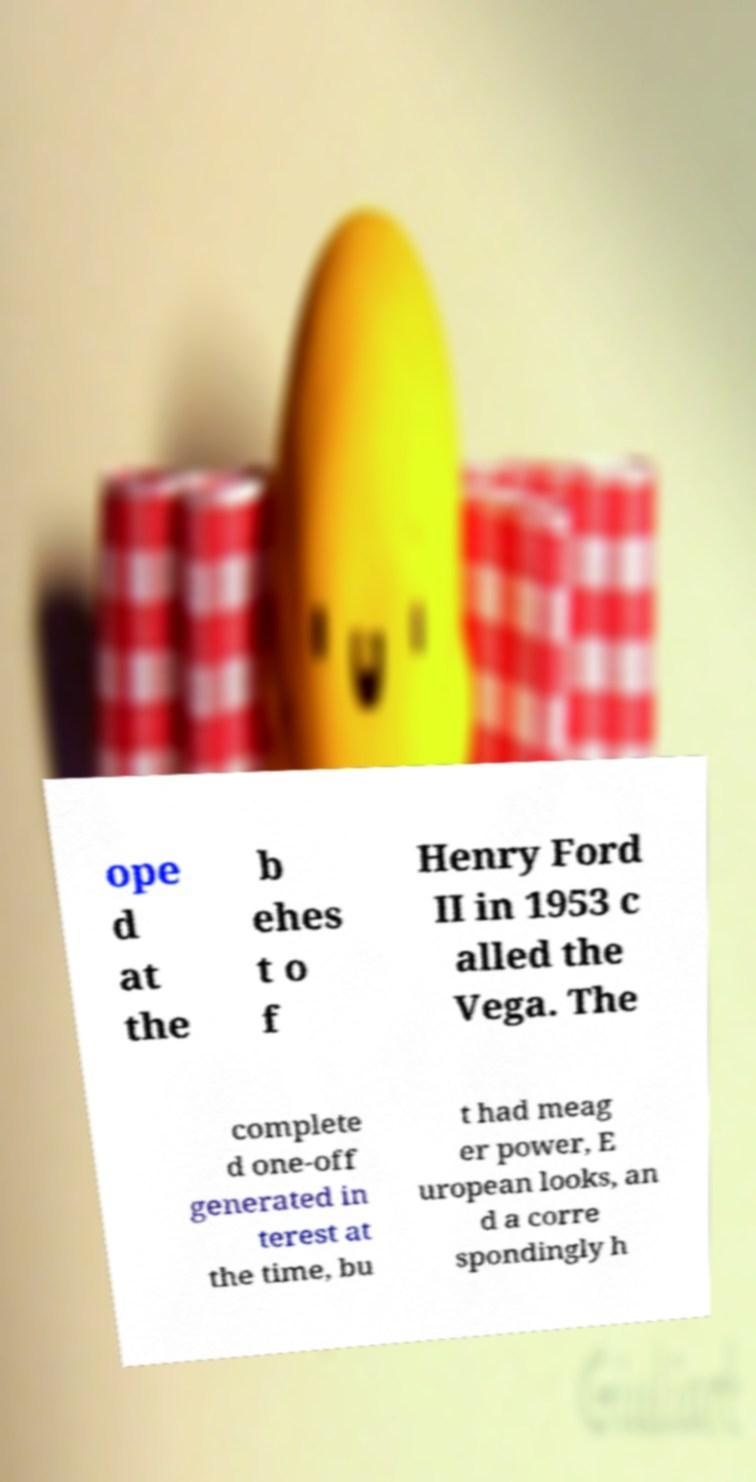Please read and relay the text visible in this image. What does it say? ope d at the b ehes t o f Henry Ford II in 1953 c alled the Vega. The complete d one-off generated in terest at the time, bu t had meag er power, E uropean looks, an d a corre spondingly h 